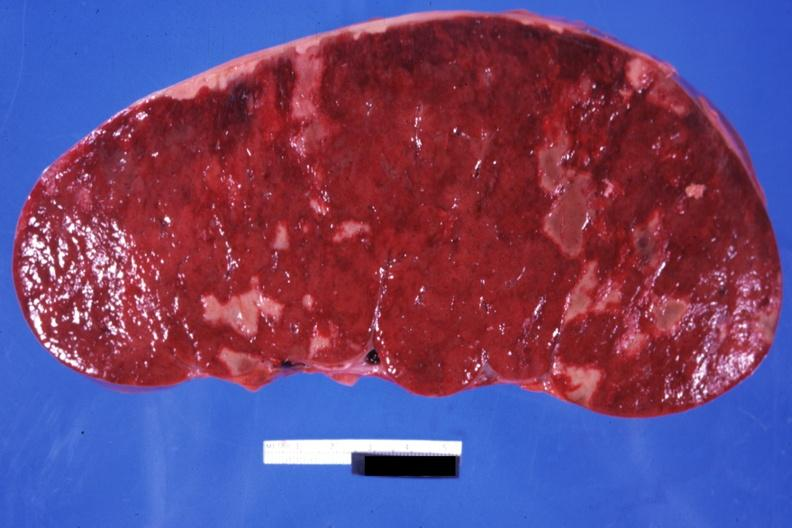s hematologic present?
Answer the question using a single word or phrase. Yes 